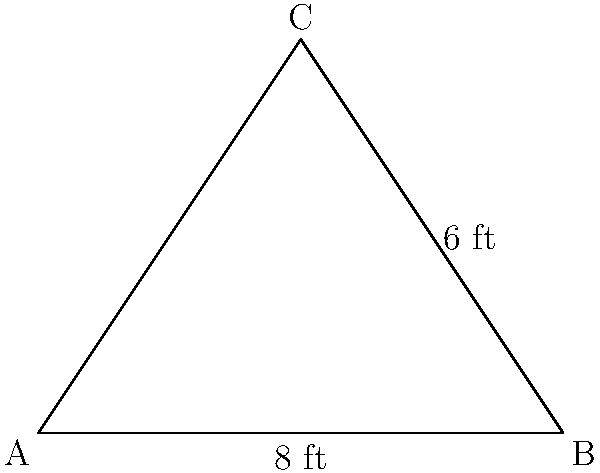A triangular banner is to be created for a medieval castle. The base of the banner measures 8 feet, and its height is 6 feet. Calculate the area of fabric needed to create this banner, assuming no extra material is required for seams or hems. To calculate the area of the triangular banner, we'll use the formula for the area of a triangle:

$$A = \frac{1}{2} \times base \times height$$

Given:
- Base of the triangle (b) = 8 feet
- Height of the triangle (h) = 6 feet

Step 1: Substitute the values into the formula
$$A = \frac{1}{2} \times 8 \times 6$$

Step 2: Multiply the numbers
$$A = \frac{1}{2} \times 48$$

Step 3: Calculate the final result
$$A = 24$$

Therefore, the area of fabric needed to create the triangular banner is 24 square feet.
Answer: 24 sq ft 